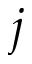<formula> <loc_0><loc_0><loc_500><loc_500>j</formula> 